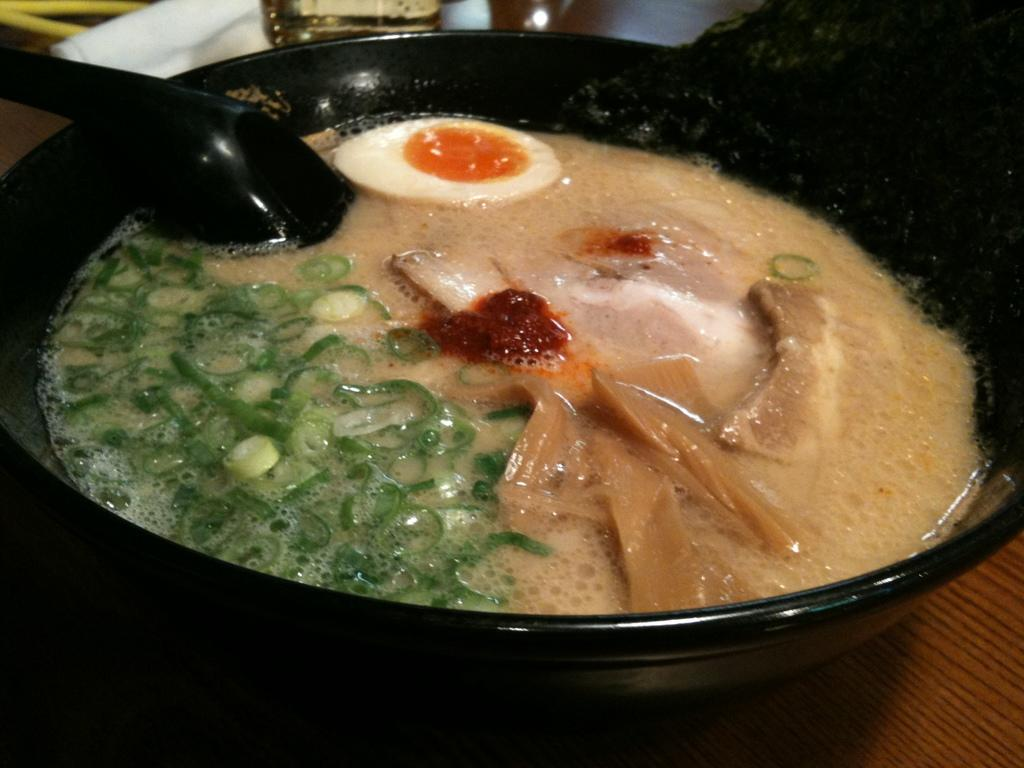What is in the pan that is visible in the image? There is a piece of egg, pieces of beans, meat, and soup in the pan. What utensil is visible in the image? There is a spoon visible in the image. What type of yard ornament can be seen in the image? There is no yard or ornament present in the image; it features a pan with various ingredients and a spoon. 